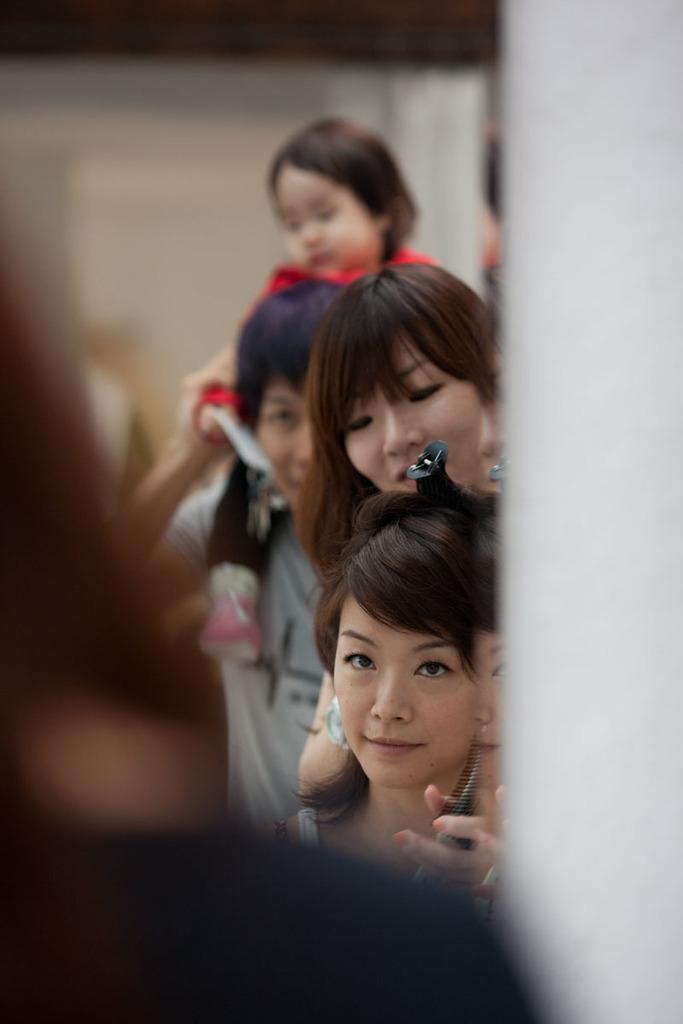Describe this image in one or two sentences. We can see glass, in this class we can see people. Background it is white. 